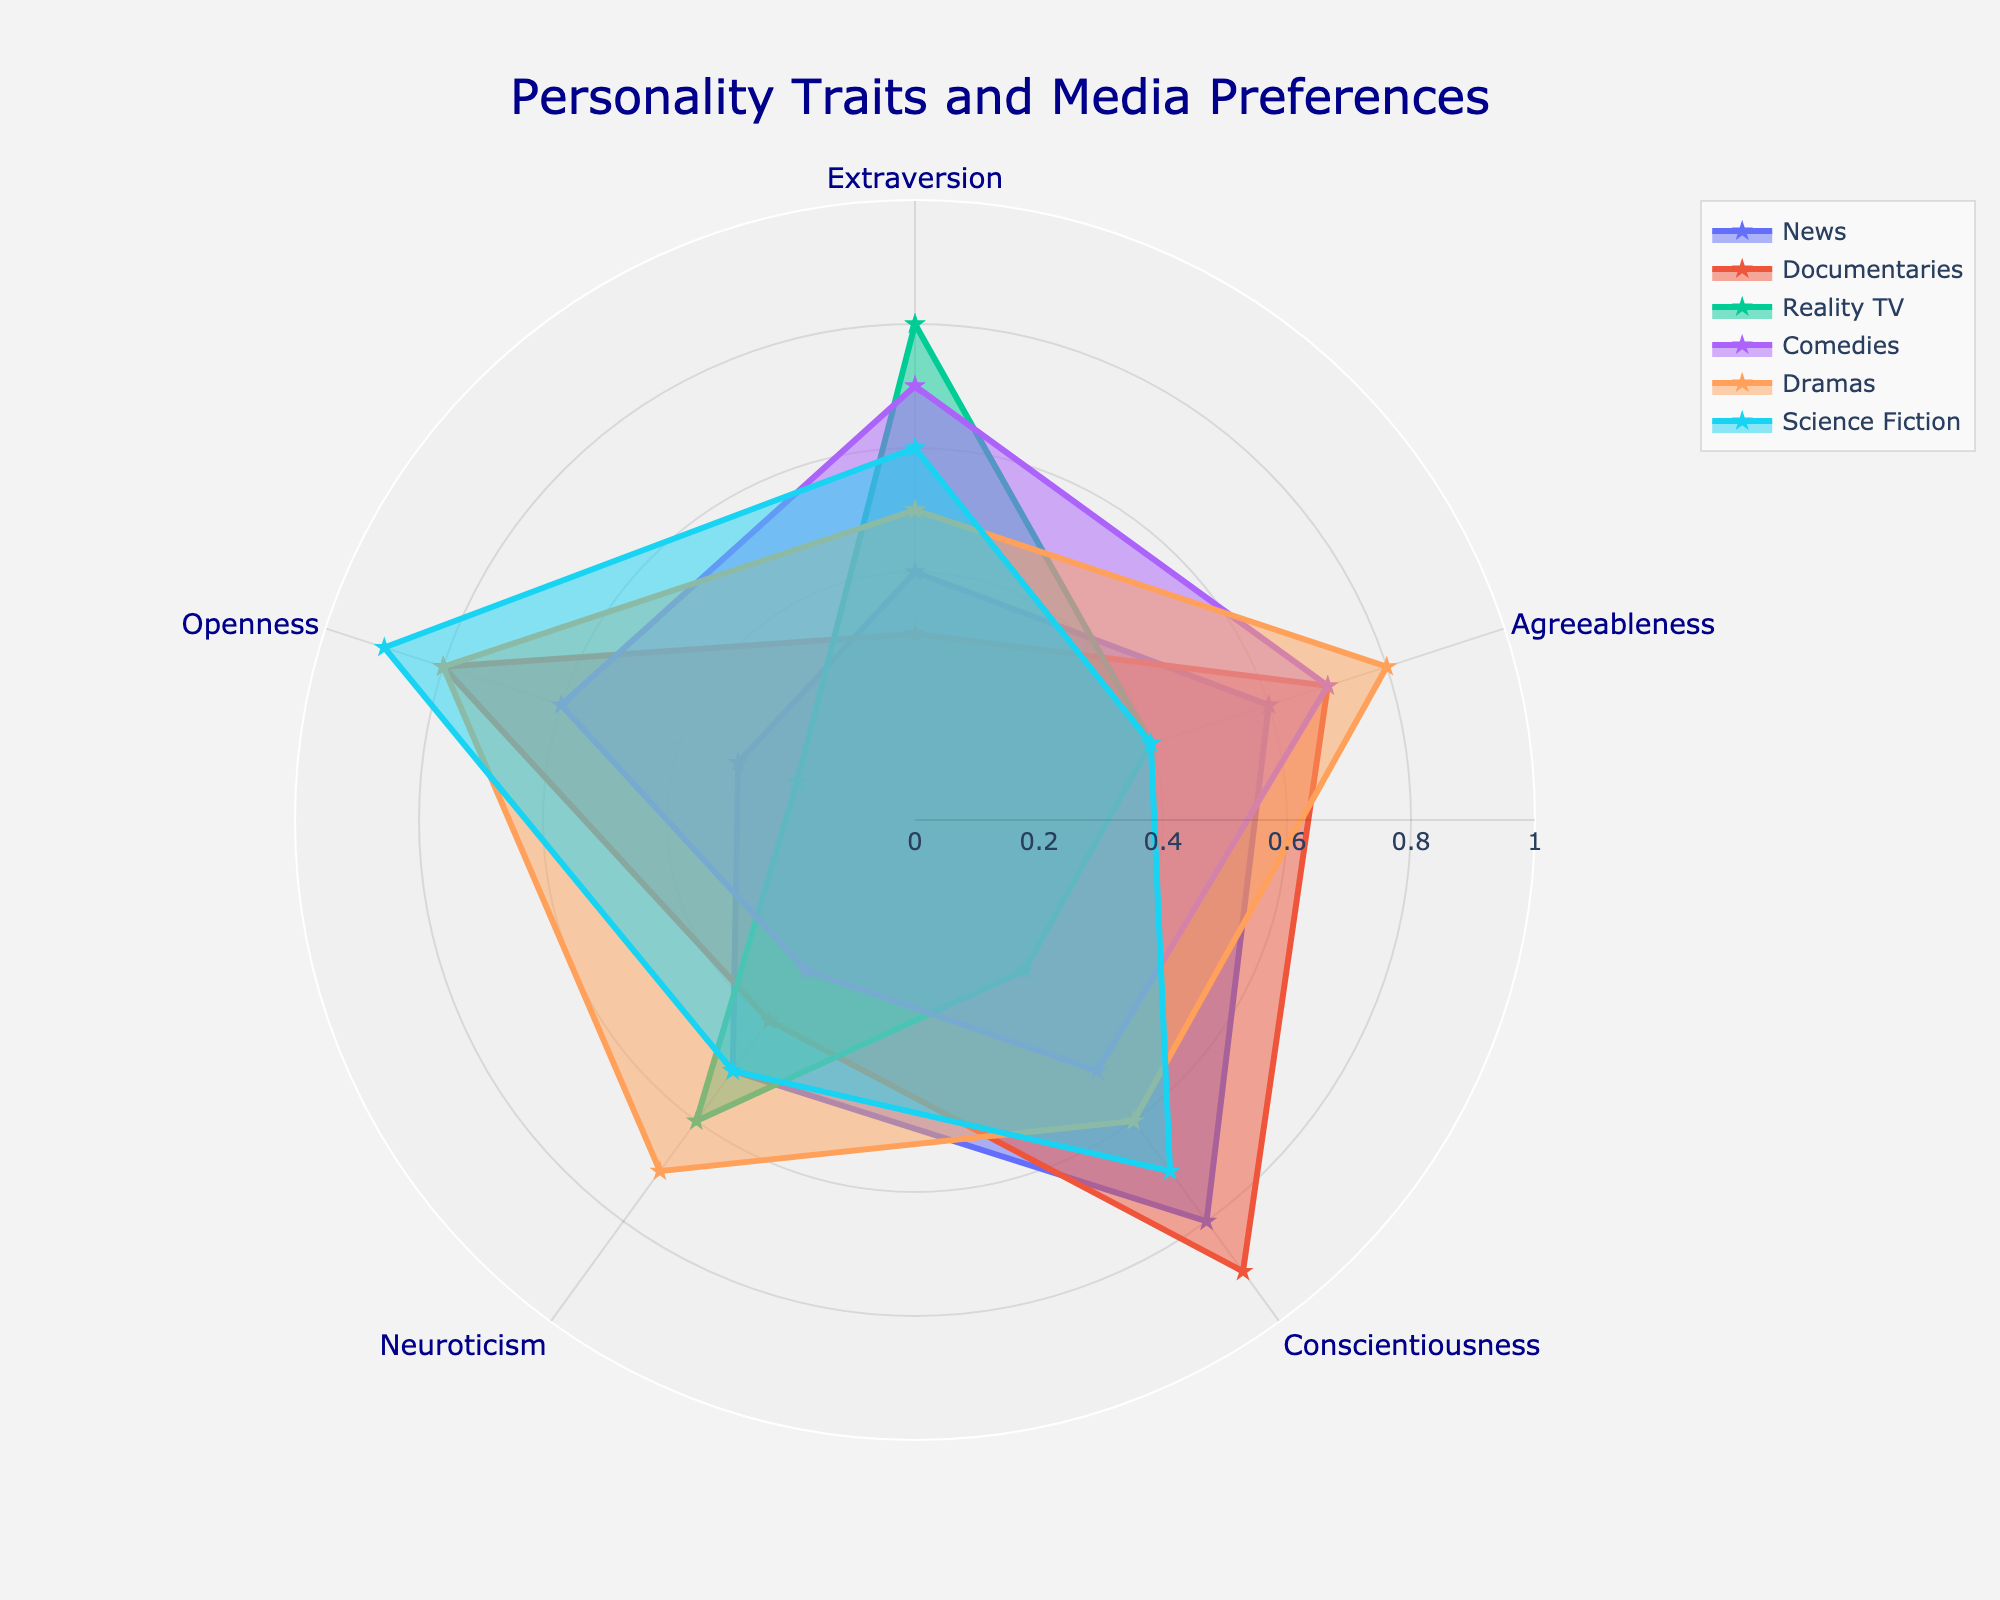What's the title of the radar chart? The title of the plot is positioned prominently at the top and states "Personality Traits and Media Preferences."
Answer: Personality Traits and Media Preferences Which personality trait shows the highest preference for Documentaries? By examining the radar chart, you can see which trait has the highest value for Documentaries. Conscientiousness reaches the closest to the outer edge, indicating the highest preference.
Answer: Conscientiousness Between Extraversion and Neuroticism, which trait has a higher preference for Reality TV? Look at the points for Reality TV for both Extraversion and Neuroticism. Extraversion scores 0.8, which is higher than Neuroticism's score of 0.6.
Answer: Extraversion What's the average preference for Science Fiction across all personality traits? The values for Science Fiction in the chart are: Extraversion (0.6), Agreeableness (0.4), Conscientiousness (0.7), Neuroticism (0.5), and Openness (0.9). Summing these values gives 3.1, and dividing by the number of traits (5) gives the average.
Answer: 0.62 Which media preference shows the most variation in preferences across personality traits? The variation can be judged by observing the spread of points for each category. Documentaries have the widest range from 0.2 (Openness) to 0.9 (Conscientiousness).
Answer: Documentaries For which type of media is Agreeableness and Neuroticism's preference equal? Reviewing the plot, both Agreeableness and Neuroticism score 0.4 for Documentaries.
Answer: Documentaries Which trait has the lowest preference for Comedies? According to the radar chart, Neuroticism has the lowest value for Comedies with a score of 0.3.
Answer: Neuroticism Compare the preferences for Dramas and Science Fiction for Openness. Which is higher? By examining the points corresponding to Openness for both Dramas and Science Fiction, Openness has a value of 0.8 for Dramas and 0.9 for Science Fiction.
Answer: Science Fiction Which personality trait shows the least variance across all types of media preferences? To determine the smallest variance, note the consistency of the trait values across all media types. Extraversion ranges from 0.3 to 0.8, Agreeableness from 0.4 to 0.8, Conscientiousness from 0.3 to 0.9, Neuroticism from 0.3 to 0.7, and Openness from 0.2 to 0.9. Agreeableness shows the least variance within the range of 0.4 to 0.8.
Answer: Agreeableness 